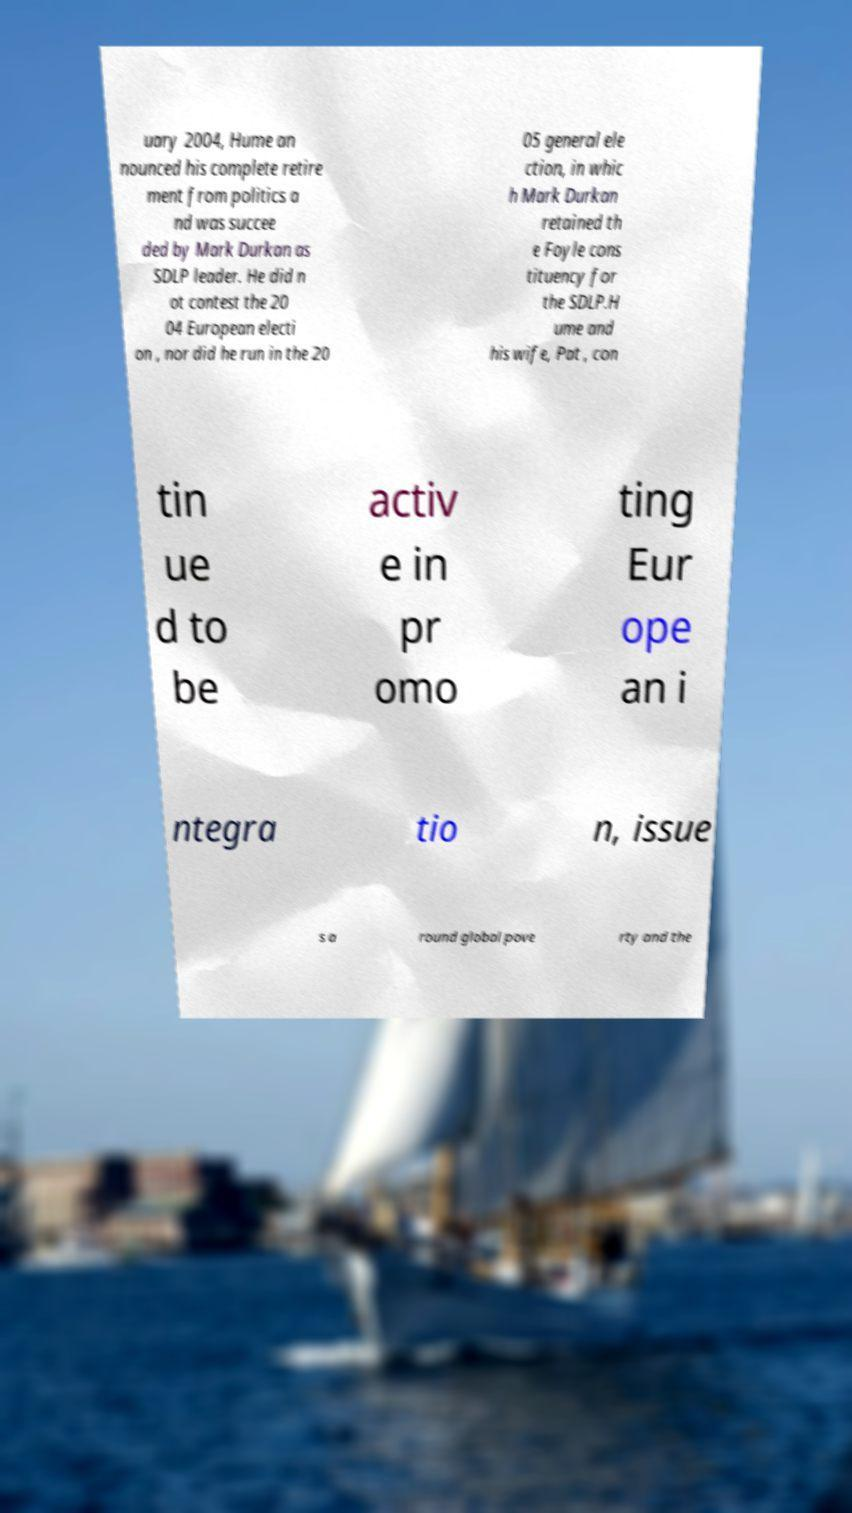I need the written content from this picture converted into text. Can you do that? uary 2004, Hume an nounced his complete retire ment from politics a nd was succee ded by Mark Durkan as SDLP leader. He did n ot contest the 20 04 European electi on , nor did he run in the 20 05 general ele ction, in whic h Mark Durkan retained th e Foyle cons tituency for the SDLP.H ume and his wife, Pat , con tin ue d to be activ e in pr omo ting Eur ope an i ntegra tio n, issue s a round global pove rty and the 